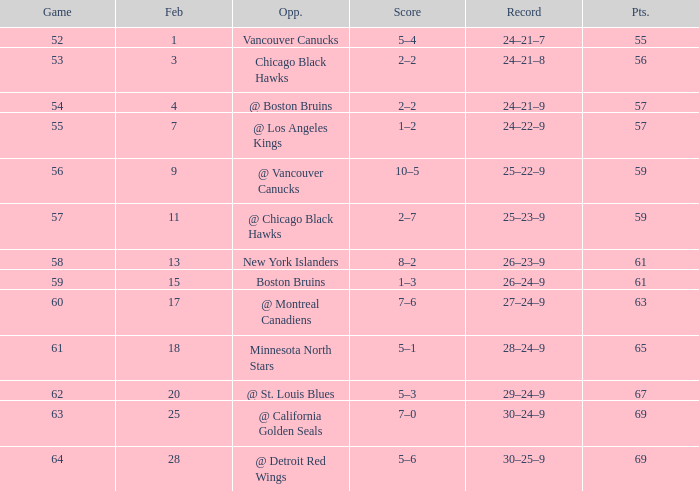How many games have a record of 30–25–9 and more points than 69? 0.0. 